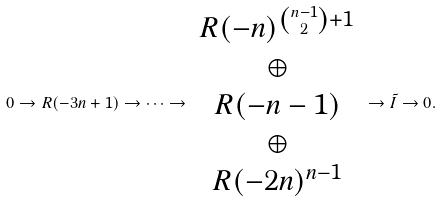Convert formula to latex. <formula><loc_0><loc_0><loc_500><loc_500>0 \to R ( - 3 n + 1 ) \to \cdots \to \begin{array} { c } R ( - n ) ^ { \binom { n - 1 } { 2 } + 1 } \\ \oplus \\ R ( - n - 1 ) \\ \oplus \\ R ( - 2 n ) ^ { n - 1 } \end{array} \to \tilde { I } \to 0 .</formula> 